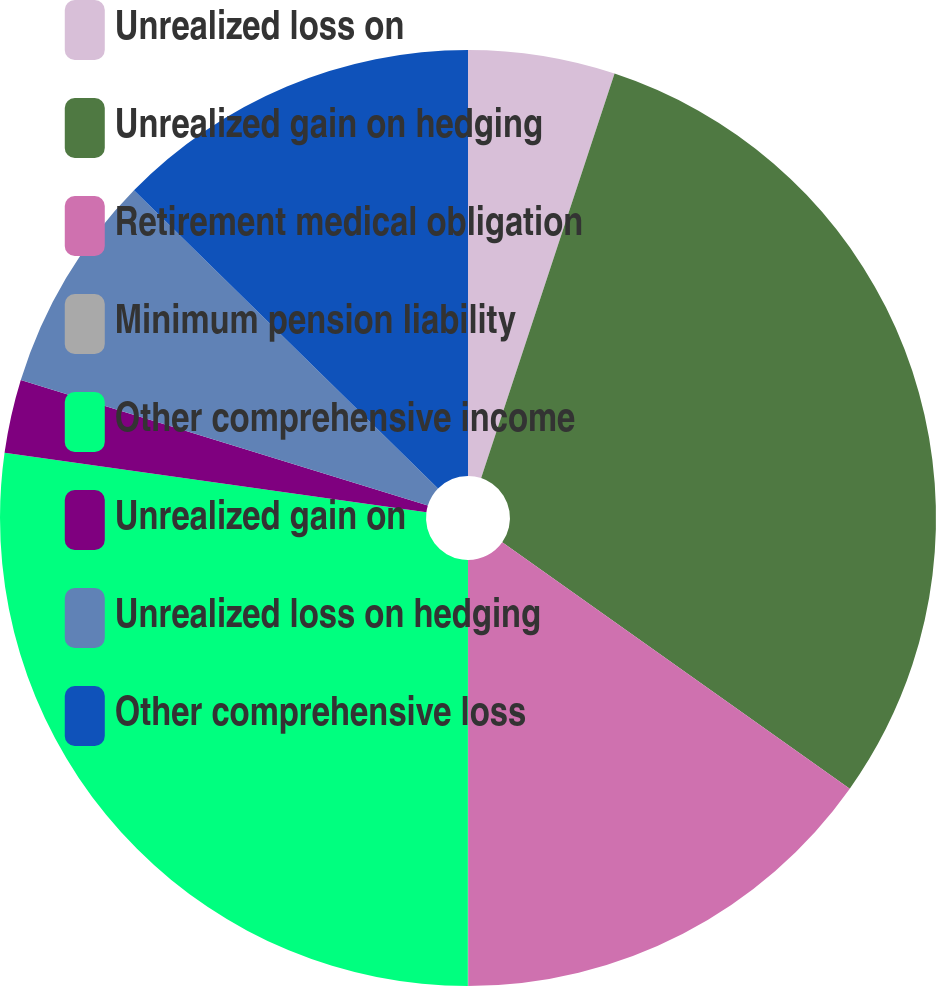<chart> <loc_0><loc_0><loc_500><loc_500><pie_chart><fcel>Unrealized loss on<fcel>Unrealized gain on hedging<fcel>Retirement medical obligation<fcel>Minimum pension liability<fcel>Other comprehensive income<fcel>Unrealized gain on<fcel>Unrealized loss on hedging<fcel>Other comprehensive loss<nl><fcel>5.07%<fcel>29.75%<fcel>15.18%<fcel>0.01%<fcel>27.22%<fcel>2.54%<fcel>7.59%<fcel>12.65%<nl></chart> 